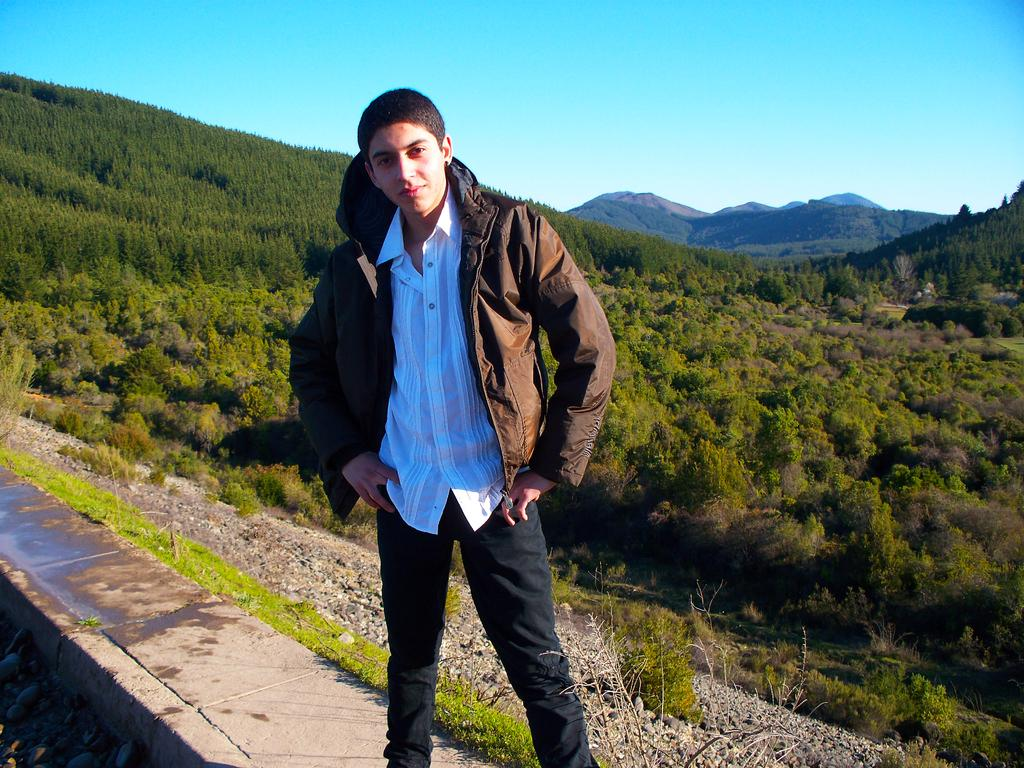What is the man in the image wearing? The man is wearing a white shirt, black pants, and a brown jacket. What can be seen in the background of the image? There are trees, grass, and the sky visible in the background of the image. What type of show is the man performing in the image? There is no indication in the image that the man is performing a show, as he is simply standing and not engaging in any performance-related activities. 